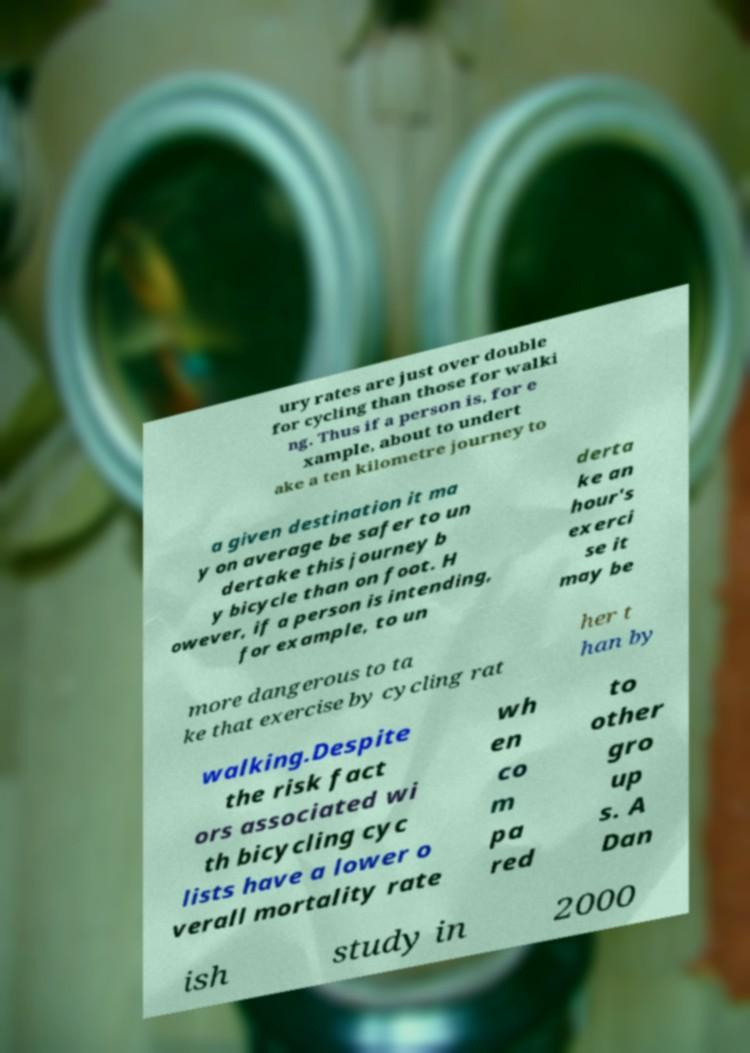Could you extract and type out the text from this image? ury rates are just over double for cycling than those for walki ng. Thus if a person is, for e xample, about to undert ake a ten kilometre journey to a given destination it ma y on average be safer to un dertake this journey b y bicycle than on foot. H owever, if a person is intending, for example, to un derta ke an hour's exerci se it may be more dangerous to ta ke that exercise by cycling rat her t han by walking.Despite the risk fact ors associated wi th bicycling cyc lists have a lower o verall mortality rate wh en co m pa red to other gro up s. A Dan ish study in 2000 